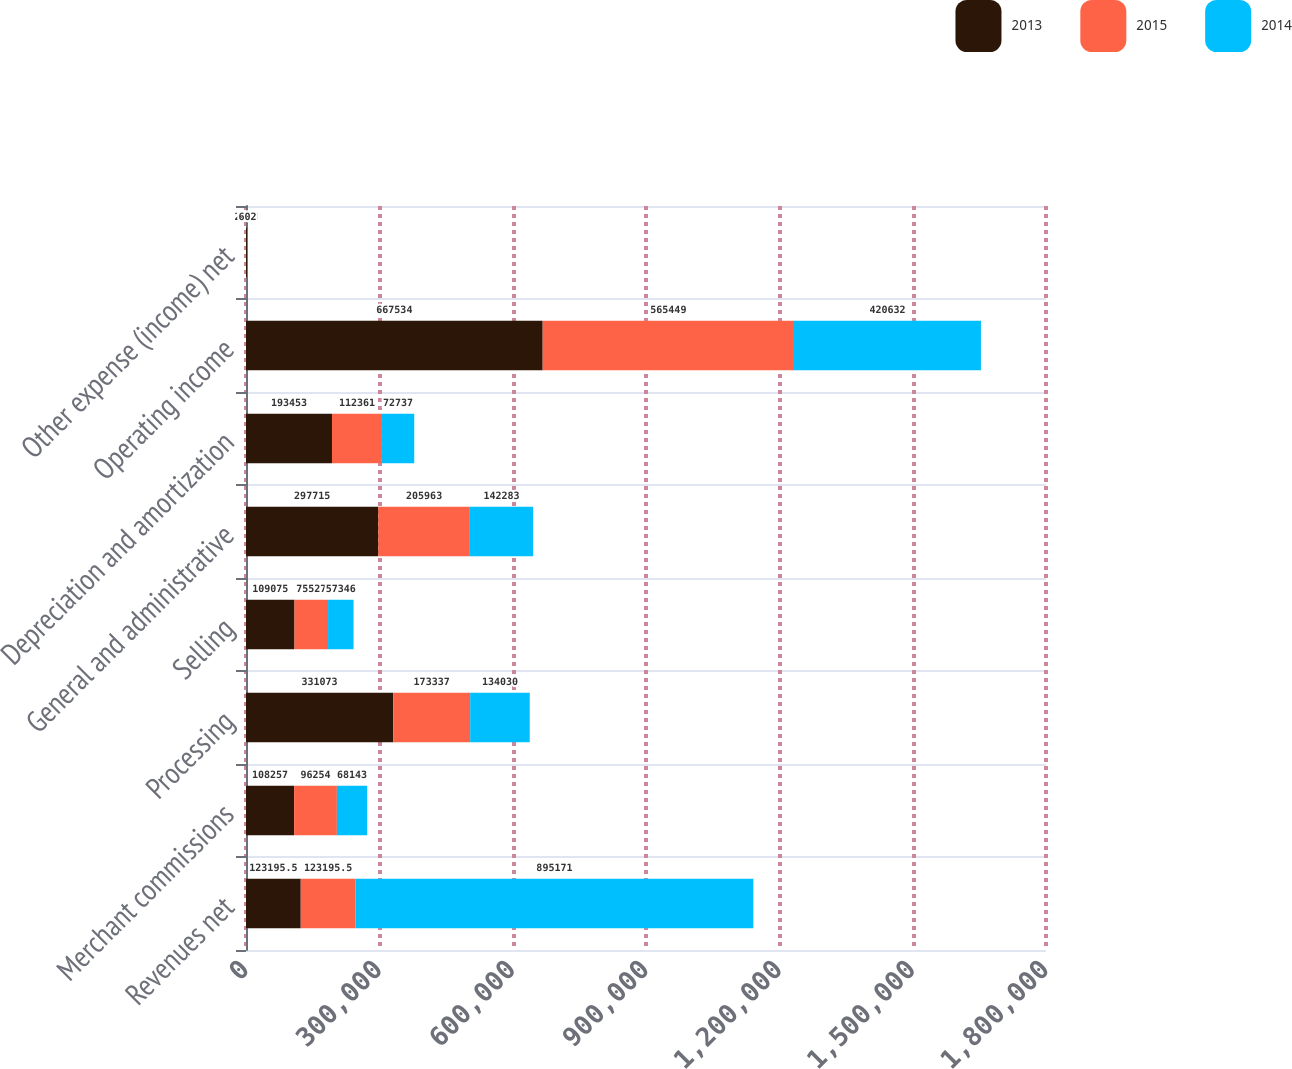Convert chart to OTSL. <chart><loc_0><loc_0><loc_500><loc_500><stacked_bar_chart><ecel><fcel>Revenues net<fcel>Merchant commissions<fcel>Processing<fcel>Selling<fcel>General and administrative<fcel>Depreciation and amortization<fcel>Operating income<fcel>Other expense (income) net<nl><fcel>2013<fcel>123196<fcel>108257<fcel>331073<fcel>109075<fcel>297715<fcel>193453<fcel>667534<fcel>2523<nl><fcel>2015<fcel>123196<fcel>96254<fcel>173337<fcel>75527<fcel>205963<fcel>112361<fcel>565449<fcel>700<nl><fcel>2014<fcel>895171<fcel>68143<fcel>134030<fcel>57346<fcel>142283<fcel>72737<fcel>420632<fcel>602<nl></chart> 